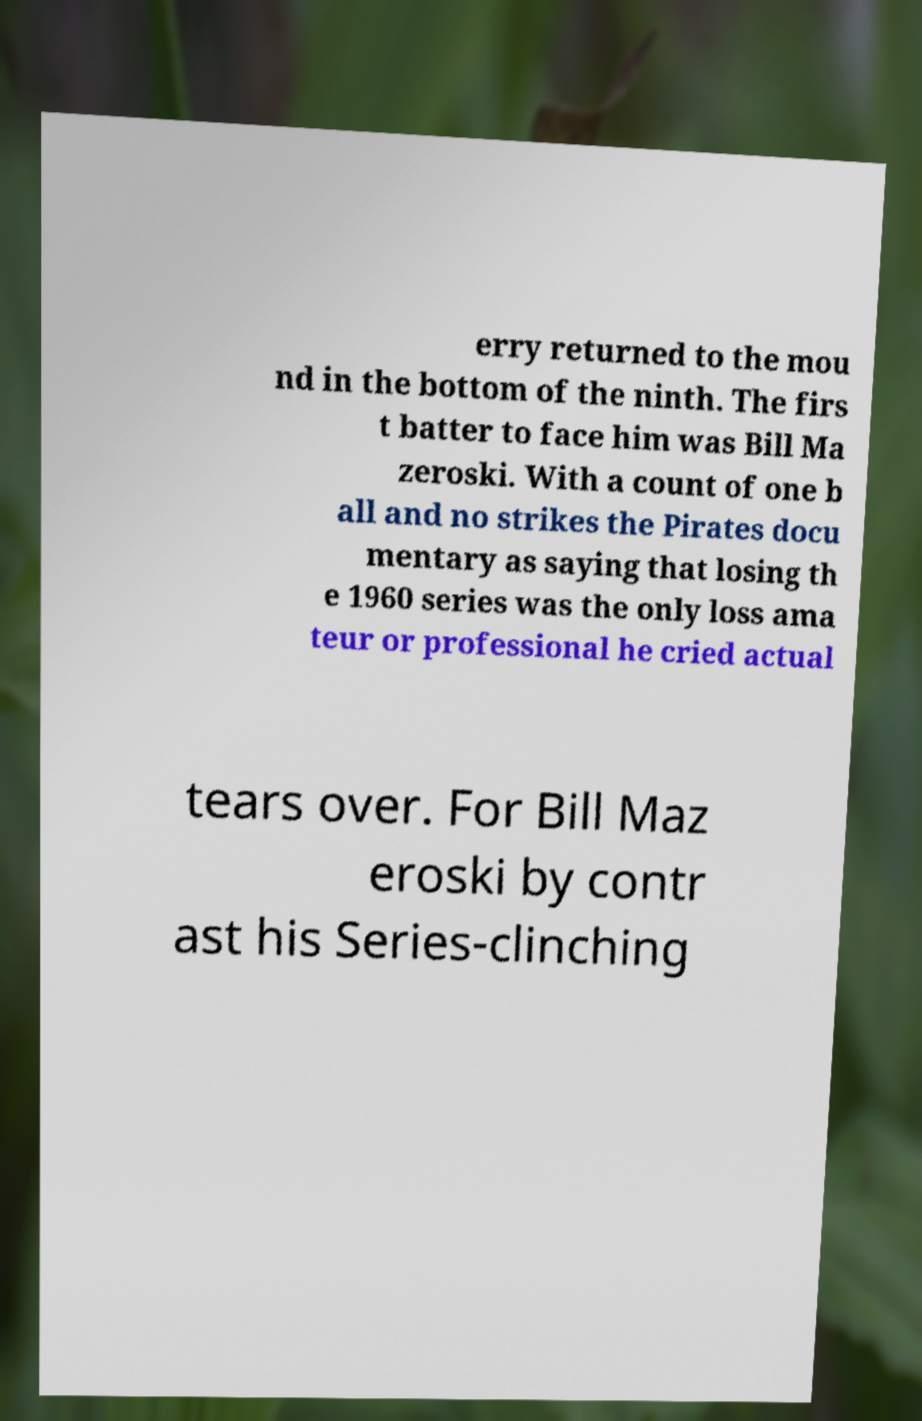There's text embedded in this image that I need extracted. Can you transcribe it verbatim? erry returned to the mou nd in the bottom of the ninth. The firs t batter to face him was Bill Ma zeroski. With a count of one b all and no strikes the Pirates docu mentary as saying that losing th e 1960 series was the only loss ama teur or professional he cried actual tears over. For Bill Maz eroski by contr ast his Series-clinching 